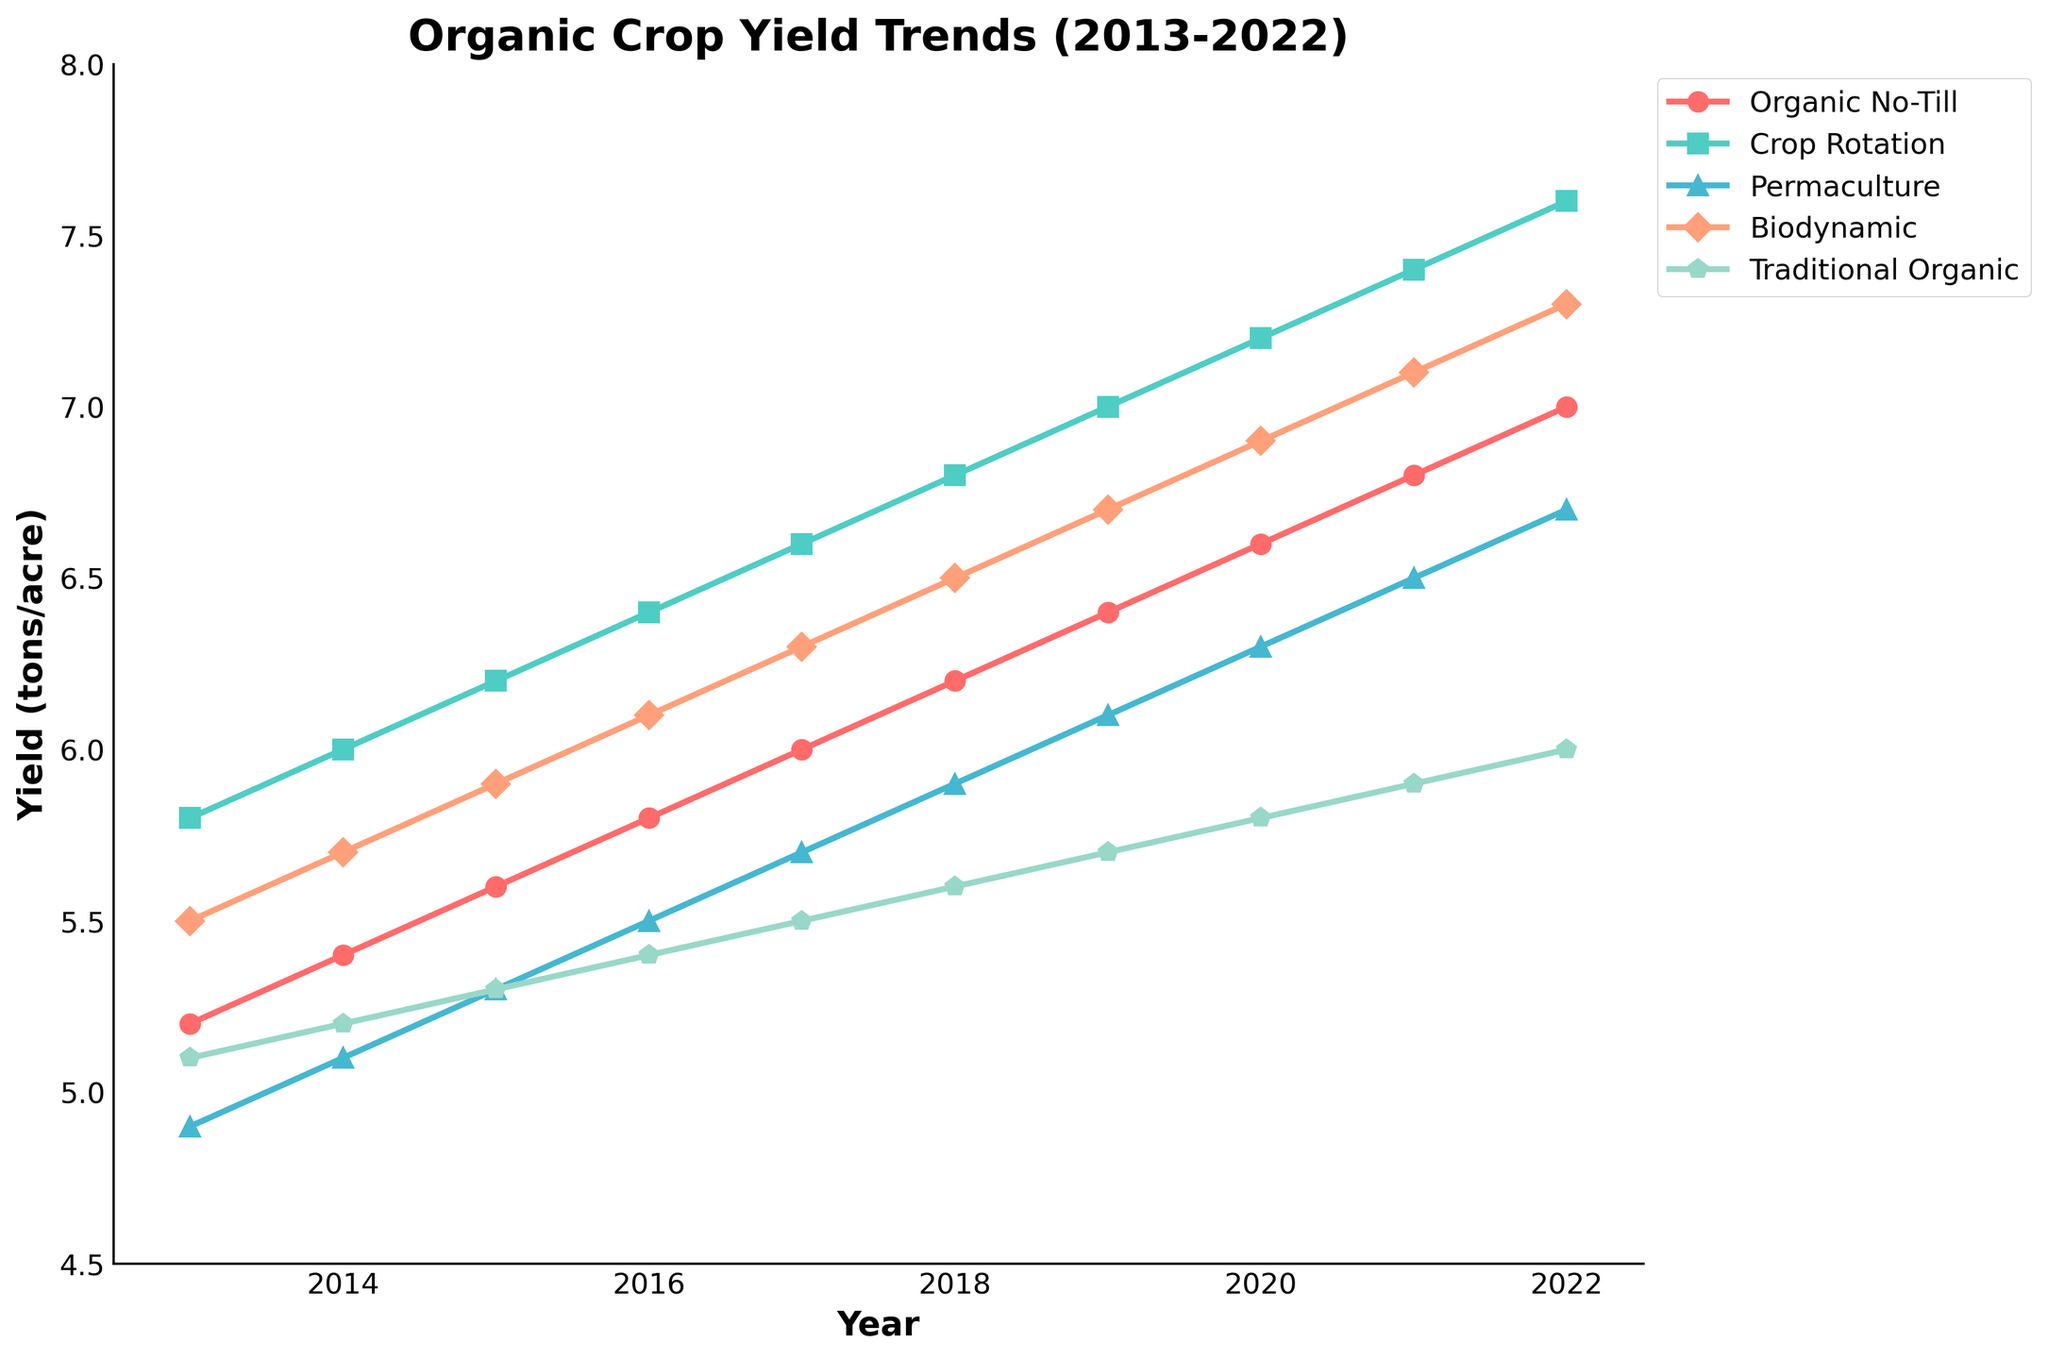What is the highest crop yield recorded for any method from 2013 to 2022? According to the figure, the highest yield recorded is for the 'Crop Rotation' method in 2022. By examining the data points on the graph, we observe that 'Crop Rotation' has a yield figure of 7.6 in 2022.
Answer: 7.6 How does the yield of Organic No-Till in 2022 compare to Permaculture in 2018? To compare these two yields, we need to locate the points for Organic No-Till in 2022 and Permaculture in 2018. Organic No-Till has a yield of 7.0 in 2022, while Permaculture has a yield of 5.9 in 2018. Comparing these values, Organic No-Till in 2022 is higher.
Answer: Organic No-Till in 2022 is higher Which method showed the most consistent increase in yield over the decade? To identify the most consistent increase, observe the slopes of the lines representing each method. 'Crop Rotation' shows a very steady upward trend with equal incremental increases each year, indicating the most consistent increase over the period.
Answer: Crop Rotation What was the average yield of Biodynamic farming method between 2017 and 2022? Calculate the average yield from 2017 to 2022 for Biodynamic method by summing the yields (6.3 + 6.5 + 6.7 + 6.9 + 7.1 + 7.3) and then dividing by the number of years (6). The sum is 40.8, so the average is 40.8 / 6 = 6.8.
Answer: 6.8 Between 2015 and 2020, which farming method demonstrated the greatest variance in yield? To determine variance, observe the range and steepness of changes in yield values. Within this time frame, Crop Rotation shows notable increases from 6.2 to 7.2, indicating the greatest variance due to the larger differences in the yield each year compared to other methods.
Answer: Crop Rotation What is the difference in yield for Traditional Organic methods between 2013 and 2022? To find the difference, subtract the 2013 yield from the 2022 yield for Traditional Organic. According to the chart, Traditional Organic had a yield of 5.1 in 2013 and 6.0 in 2022. The operation 6.0 - 5.1 results in 0.9.
Answer: 0.9 Which year did the Permaculture method first reach a yield of 6.0 tons per acre or higher? Locate the Permaculture trend line and identify the first year where the yield reaches 6.0 or more. The chart indicates this occurs in 2019, with a yield of 6.1.
Answer: 2019 What is the average yield for all the methods combined in the year 2017? First, sum the yields for all methods in 2017 (6.0 + 6.6 + 5.7 + 6.3 + 5.5). The total is 30.1. Then, divide by the number of methods (5). The average yield is 30.1 / 5 = 6.02.
Answer: 6.02 How did the yield for Crop Rotation change from 2016 to 2020? Observe the yield values from 2016 to 2020 for Crop Rotation. The yield increased from 6.4 in 2016 to 7.2 in 2020. The change can be calculated as 7.2 - 6.4 = 0.8. Therefore, there was an increase of 0.8.
Answer: Increased by 0.8 For which method did the yield increase the least from 2013 to 2022? To determine the least increase, evaluate the beginning and ending yields for each method. Traditional Organic shows yields of 5.1 in 2013 and 6.0 in 2022, with an increase of 0.9, which is the smallest increase among all methods.
Answer: Traditional Organic 